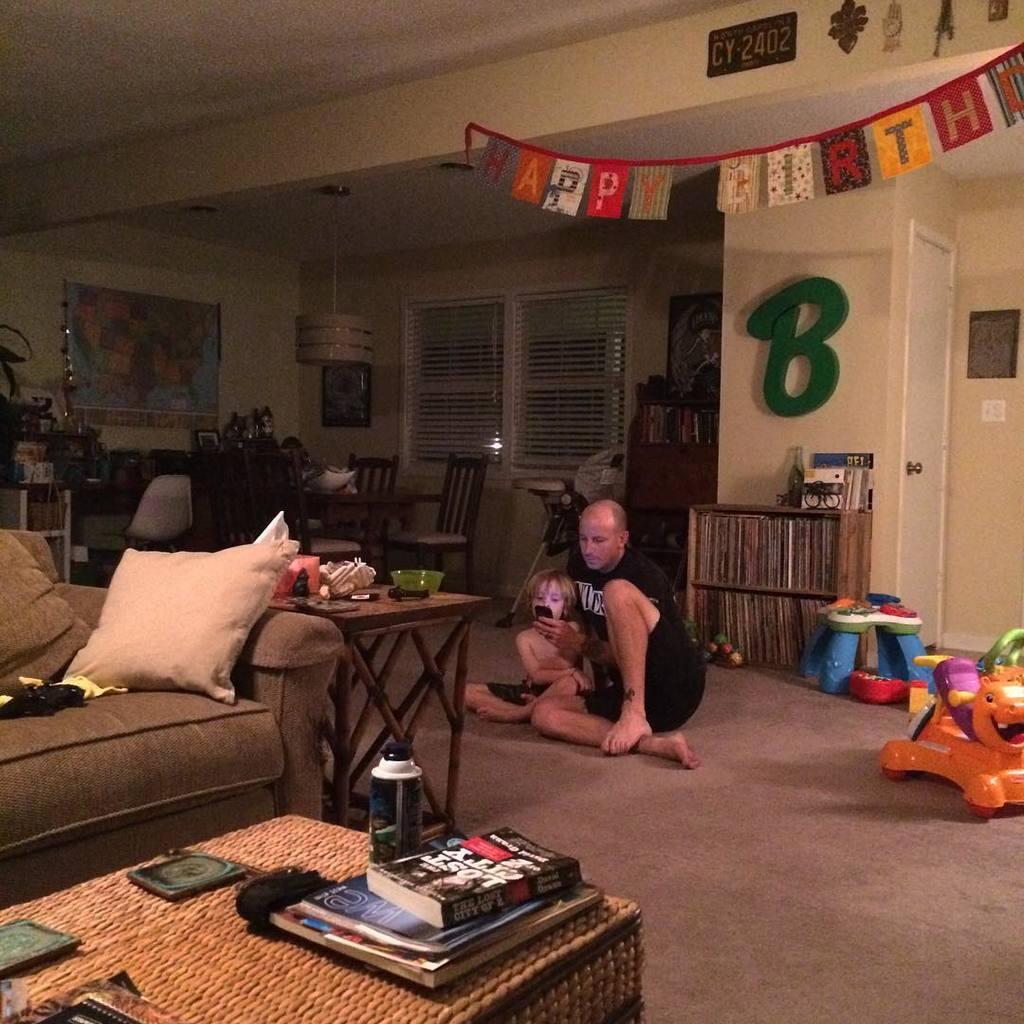Describe this image in one or two sentences. In this image I see a man who is sitting with the child on the floor, I can also there is a sofa, few tables and things on it. I can also see there are few toys. In the background I see the chairs, window, rack full of books in it and the wall. 